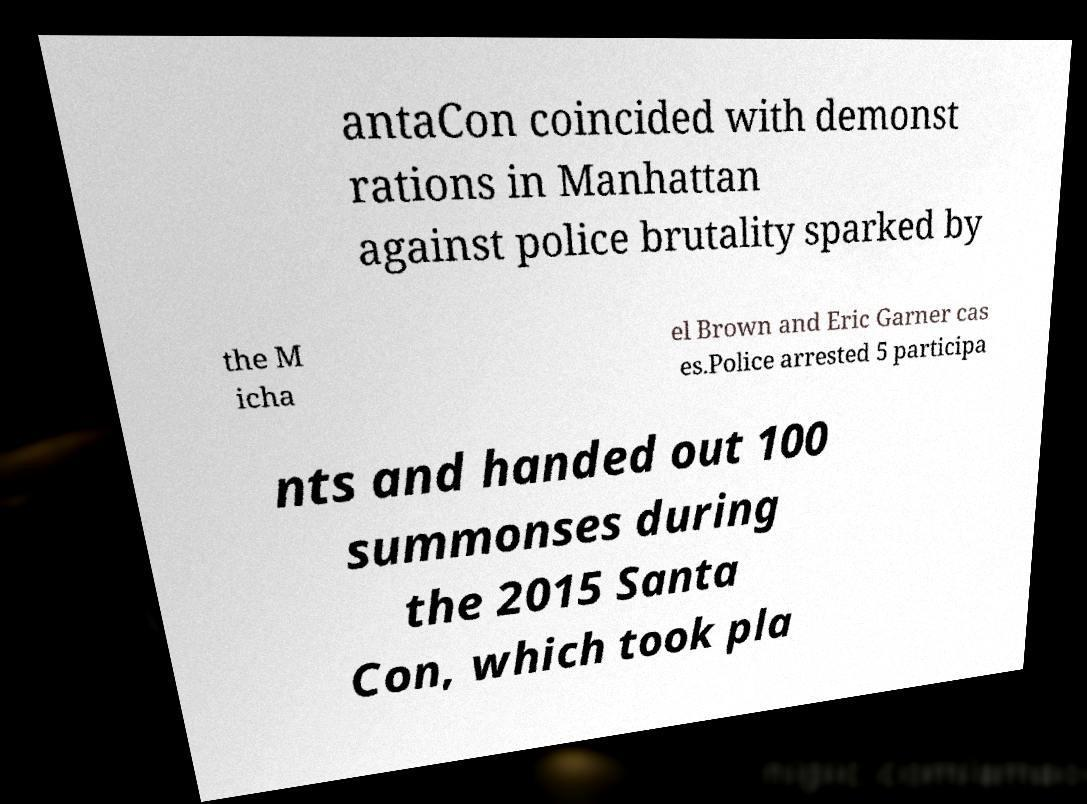Please read and relay the text visible in this image. What does it say? antaCon coincided with demonst rations in Manhattan against police brutality sparked by the M icha el Brown and Eric Garner cas es.Police arrested 5 participa nts and handed out 100 summonses during the 2015 Santa Con, which took pla 